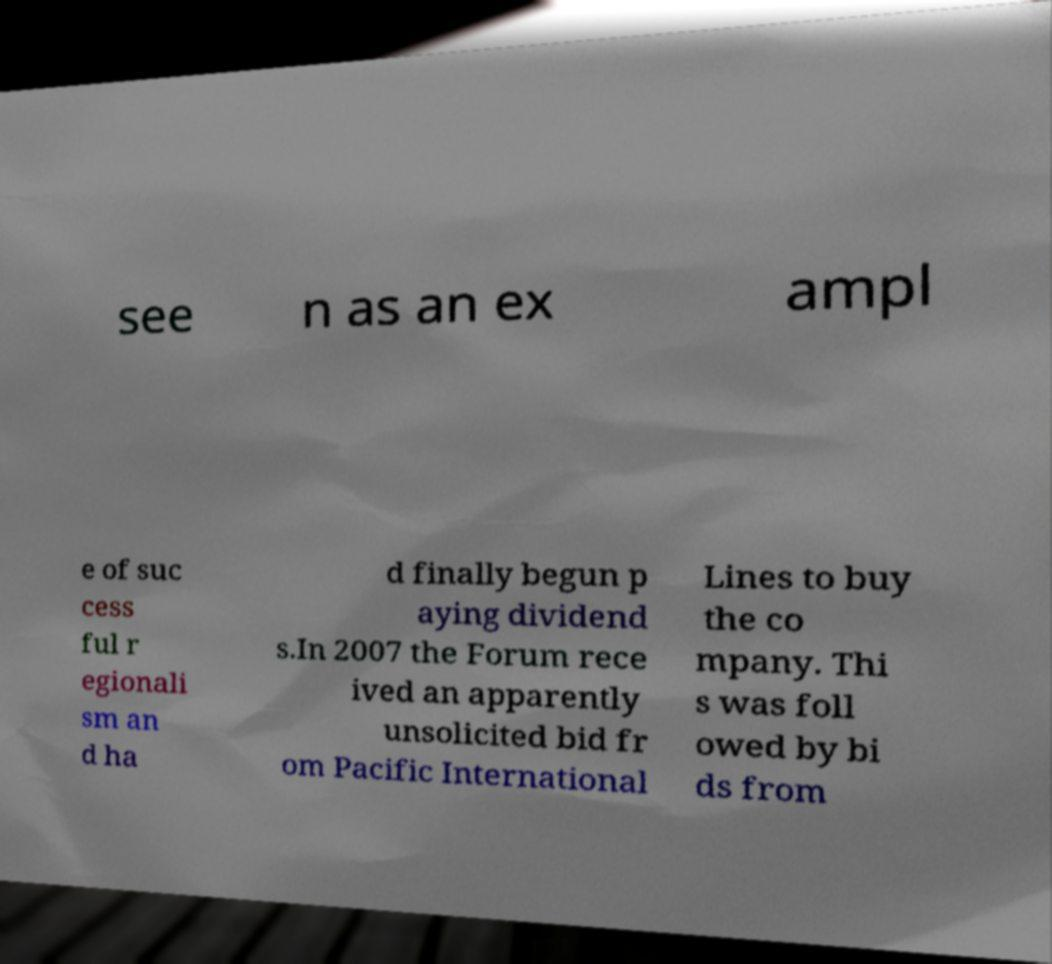For documentation purposes, I need the text within this image transcribed. Could you provide that? see n as an ex ampl e of suc cess ful r egionali sm an d ha d finally begun p aying dividend s.In 2007 the Forum rece ived an apparently unsolicited bid fr om Pacific International Lines to buy the co mpany. Thi s was foll owed by bi ds from 